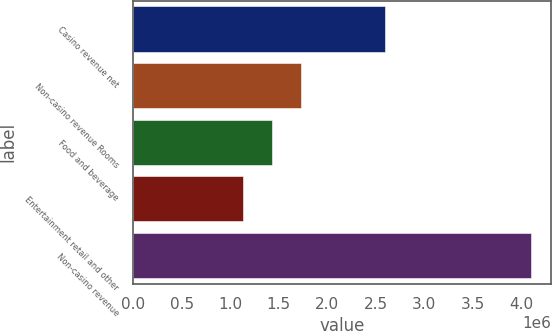Convert chart. <chart><loc_0><loc_0><loc_500><loc_500><bar_chart><fcel>Casino revenue net<fcel>Non-casino revenue Rooms<fcel>Food and beverage<fcel>Entertainment retail and other<fcel>Non-casino revenue<nl><fcel>2.59957e+06<fcel>1.72477e+06<fcel>1.42753e+06<fcel>1.1303e+06<fcel>4.10266e+06<nl></chart> 